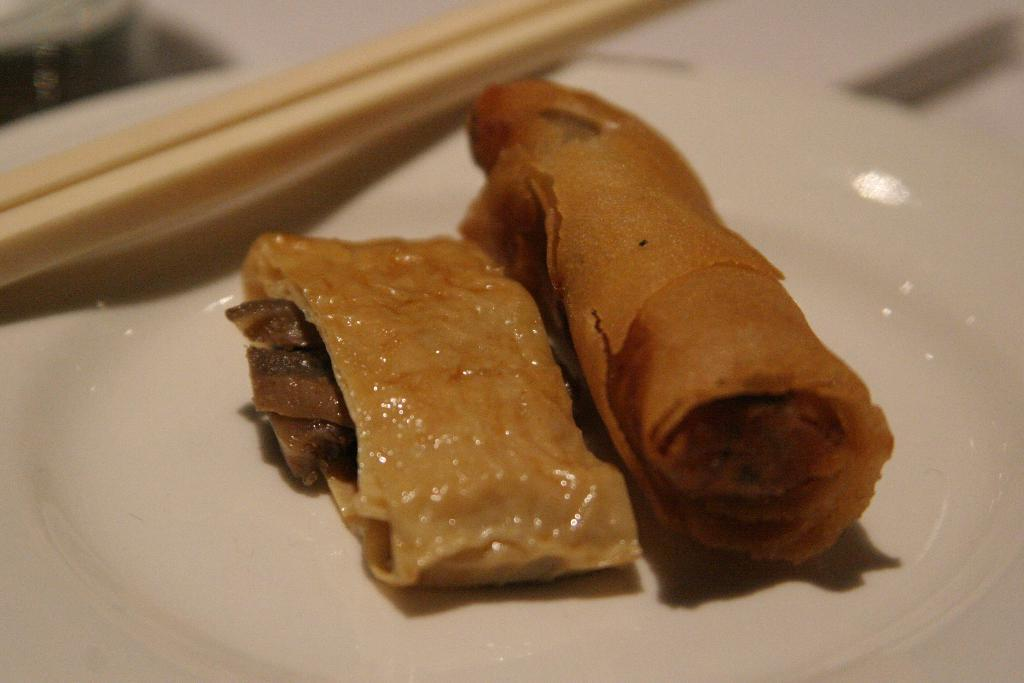What is on the plate that is visible in the image? The plate is filled with food items. What objects can be seen besides the plate in the image? There are toothpicks visible in the image. Where is the dad sitting in the image? There is no dad present in the image; it only features a white plate filled with food items and toothpicks. 